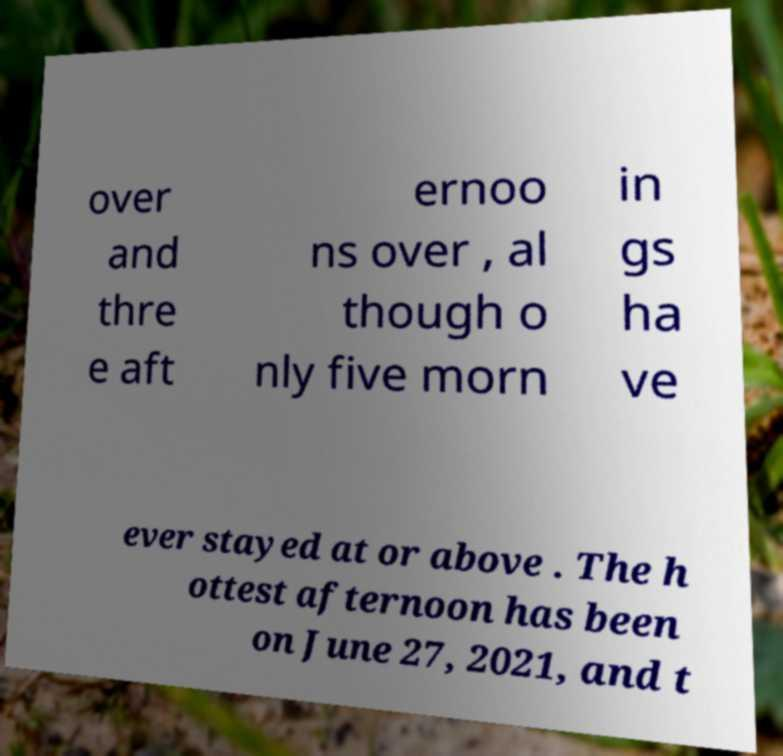Please identify and transcribe the text found in this image. over and thre e aft ernoo ns over , al though o nly five morn in gs ha ve ever stayed at or above . The h ottest afternoon has been on June 27, 2021, and t 